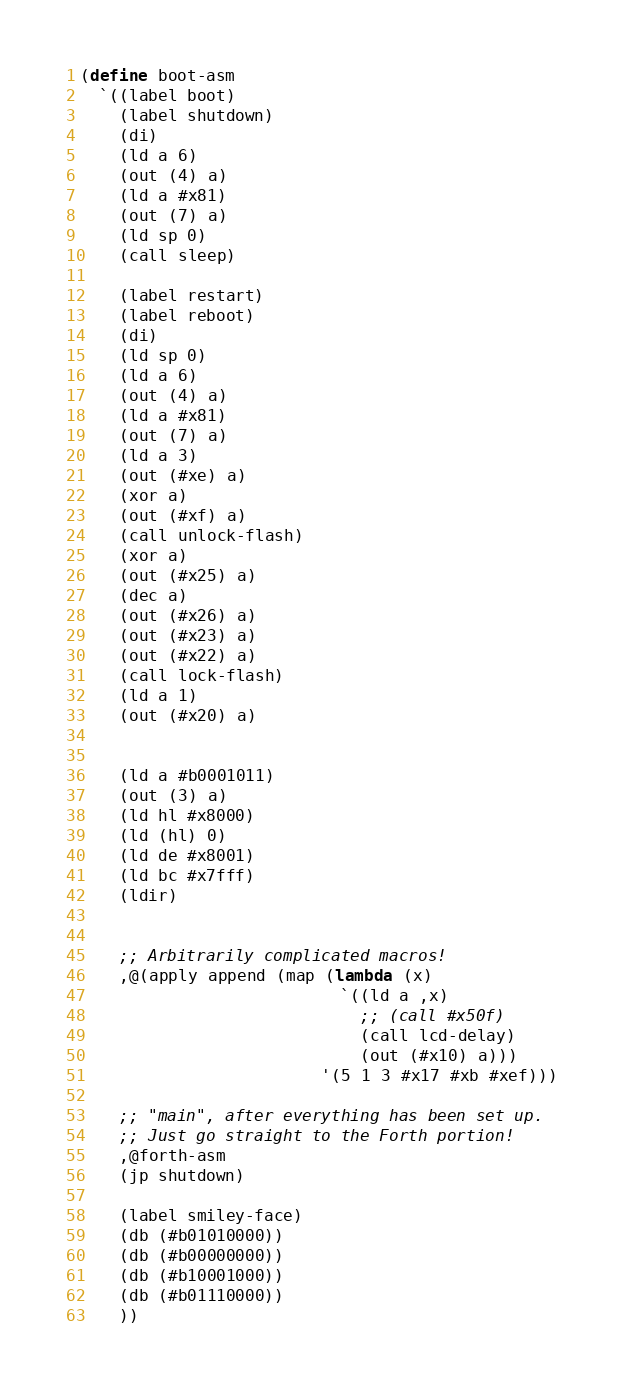Convert code to text. <code><loc_0><loc_0><loc_500><loc_500><_Scheme_>(define boot-asm
  `((label boot)
    (label shutdown)
    (di)
    (ld a 6)
    (out (4) a)
    (ld a #x81)
    (out (7) a)
    (ld sp 0)
    (call sleep)

    (label restart)
    (label reboot)
    (di)
    (ld sp 0)
    (ld a 6)
    (out (4) a)
    (ld a #x81)
    (out (7) a)
    (ld a 3)
    (out (#xe) a)
    (xor a)
    (out (#xf) a)
    (call unlock-flash)
    (xor a)
    (out (#x25) a)
    (dec a)
    (out (#x26) a)
    (out (#x23) a)
    (out (#x22) a)
    (call lock-flash)
    (ld a 1)
    (out (#x20) a)


    (ld a #b0001011)
    (out (3) a)
    (ld hl #x8000)
    (ld (hl) 0)
    (ld de #x8001)
    (ld bc #x7fff)
    (ldir)

    
    ;; Arbitrarily complicated macros!
    ,@(apply append (map (lambda (x)
                           `((ld a ,x)
                             ;; (call #x50f)
                             (call lcd-delay)
                             (out (#x10) a)))
                         '(5 1 3 #x17 #xb #xef)))

    ;; "main", after everything has been set up.
    ;; Just go straight to the Forth portion!
    ,@forth-asm
    (jp shutdown)

    (label smiley-face)
    (db (#b01010000))
    (db (#b00000000))
    (db (#b10001000))
    (db (#b01110000))
    ))
</code> 